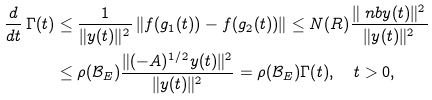Convert formula to latex. <formula><loc_0><loc_0><loc_500><loc_500>\frac { d } { d t } \, \Gamma ( t ) & \leq \frac { 1 } { \| y ( t ) \| ^ { 2 } } \left \| f ( g _ { 1 } ( t ) ) - f ( g _ { 2 } ( t ) ) \right \| \leq N ( R ) \frac { \| \ n b y ( t ) \| ^ { 2 } } { \| y ( t ) \| ^ { 2 } } \\ & \leq \rho ( \mathcal { B } _ { E } ) \frac { \| ( - A ) ^ { 1 / 2 } y ( t ) \| ^ { 2 } } { \| y ( t ) \| ^ { 2 } } = \rho ( \mathcal { B } _ { E } ) \Gamma ( t ) , \quad t > 0 ,</formula> 